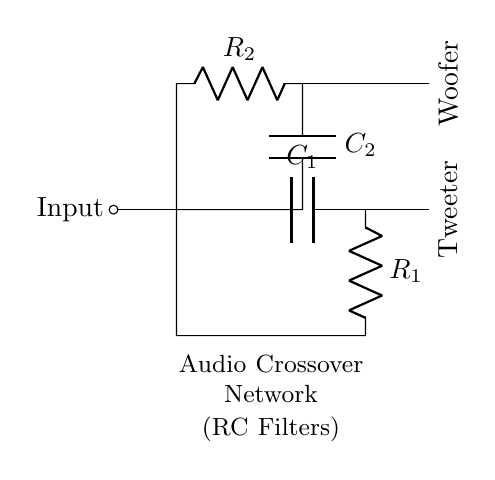What components are used in the high-pass filter? The high-pass filter consists of a capacitor labeled C1 and a resistor labeled R1, which are arranged such that the capacitor is in series and the resistor is in parallel with the load.
Answer: C1, R1 What type of filters are represented in the circuit? The circuit contains both a high-pass filter for tweeters and a low-pass filter for woofers, identified by the configuration of capacitors and resistors.
Answer: High-pass and low-pass What is the orientation of the tweeter output in the circuit? The tweeter output is oriented vertically on the right-hand side and, as indicated, is connected to the node that follows component arrangement for the high-pass filter.
Answer: Vertical Which component has a larger impedance at high frequencies? Capacitor C1 inherently offers lower impedance at high frequencies, making it a key player in allowing those frequencies to pass through while blocking lower frequencies.
Answer: C1 How does the low-pass filter affect the frequency response? The low-pass filter allows frequencies below the cutoff frequency to pass while attenuating frequencies above that level, establishing a range suitable for the woofer output.
Answer: Attenuates high frequencies What is the role of resistor R2 in the circuit? Resistor R2 is part of the low-pass filter circuit and helps determine the cutoff frequency along with capacitor C2, regulating the amount of current flowing through the woofer relative to frequency.
Answer: Determine cutoff frequency 